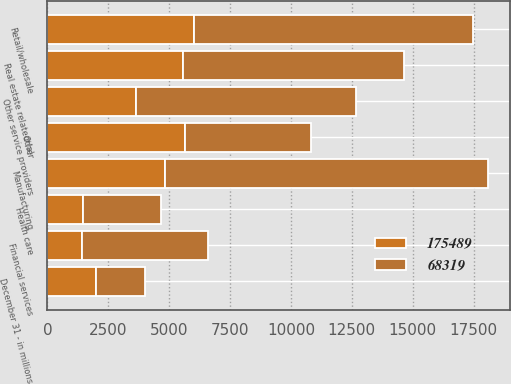Convert chart to OTSL. <chart><loc_0><loc_0><loc_500><loc_500><stacked_bar_chart><ecel><fcel>December 31 - in millions<fcel>Retail/wholesale<fcel>Manufacturing<fcel>Other service providers<fcel>Real estate related (a)<fcel>Financial services<fcel>Health care<fcel>Other<nl><fcel>68319<fcel>2008<fcel>11482<fcel>13263<fcel>9038<fcel>9107<fcel>5194<fcel>3201<fcel>5194<nl><fcel>175489<fcel>2007<fcel>6013<fcel>4814<fcel>3639<fcel>5556<fcel>1419<fcel>1464<fcel>5634<nl></chart> 